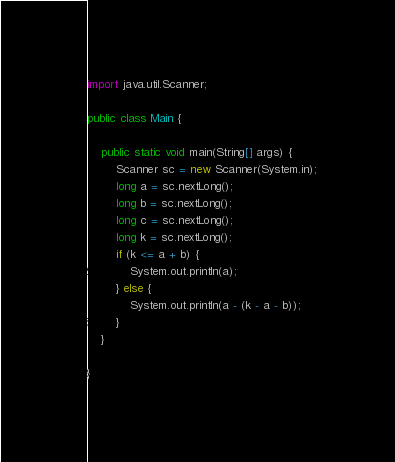<code> <loc_0><loc_0><loc_500><loc_500><_Java_>import java.util.Scanner;

public class Main {

    public static void main(String[] args) {
        Scanner sc = new Scanner(System.in);
        long a = sc.nextLong();
        long b = sc.nextLong();
        long c = sc.nextLong();
        long k = sc.nextLong();
        if (k <= a + b) {
            System.out.println(a);
        } else {
            System.out.println(a - (k - a - b));
        }
    }

}
</code> 